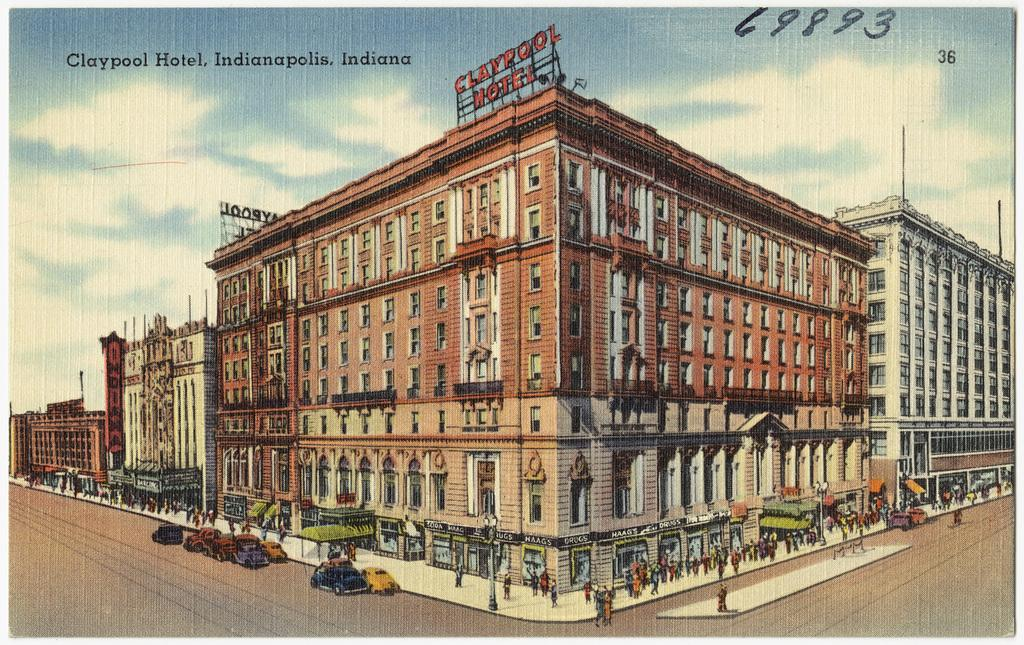What is the primary subject of the image? The image contains many buildings. What else can be seen in front of the buildings? There are vehicles in front of the buildings. Are there any people visible in the image? Yes, some people are moving on the footpath. What type of writing can be seen on the faces of the people in the image? There is no writing visible on the faces of the people in the image. 